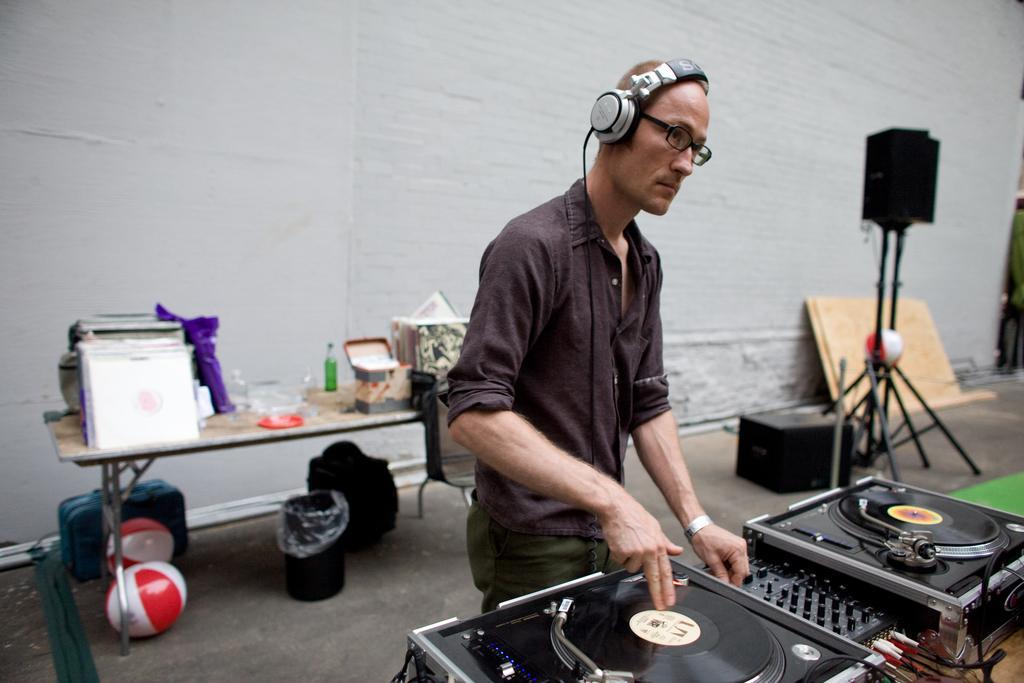Can you describe this image briefly? In this image I can see the person is standing and wearing headset. I can see the DJ-equipment and few objects on the table. I can see the dustbin, bags, stand, speaker and the wall. 